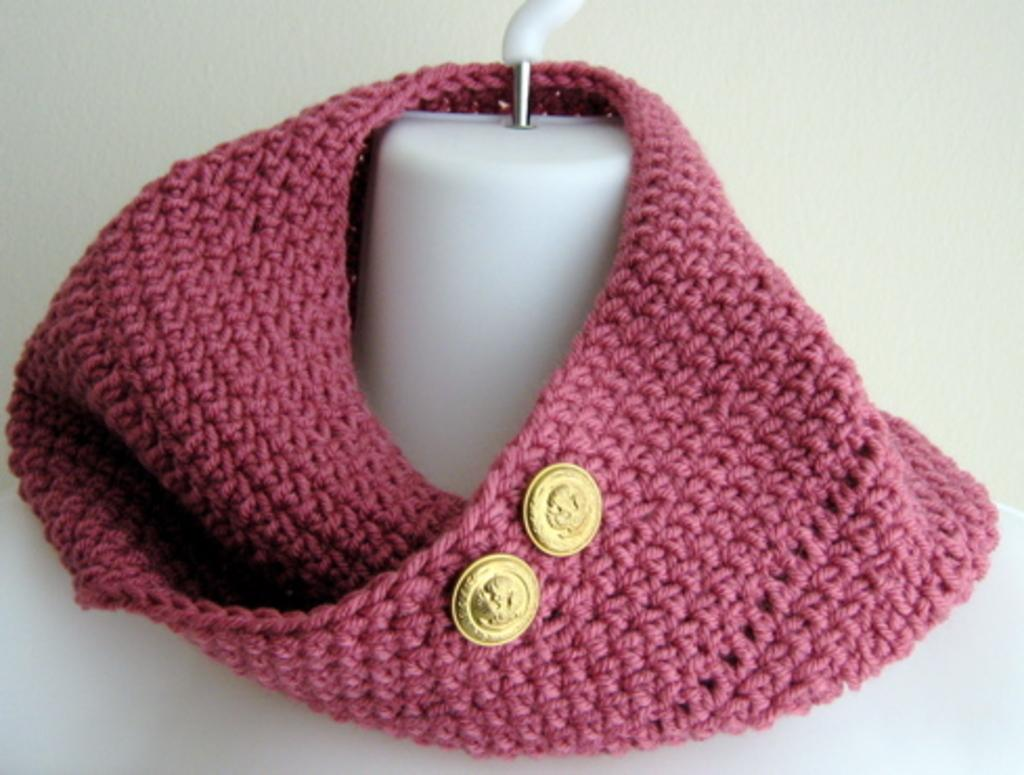What is the main subject in the image? There is a mannequin in the image. What is around the neck of the mannequin? There is a pink color cloth around the neck of the mannequin. What color are the buttons visible in the image? There are two gold color buttons in the image. What color is the background of the image? The background of the image is white. Is there a garden visible in the image? No, there is no garden present in the image. What type of humor can be seen in the image? There is no humor depicted in the image; it features a mannequin with a pink cloth and gold buttons. 